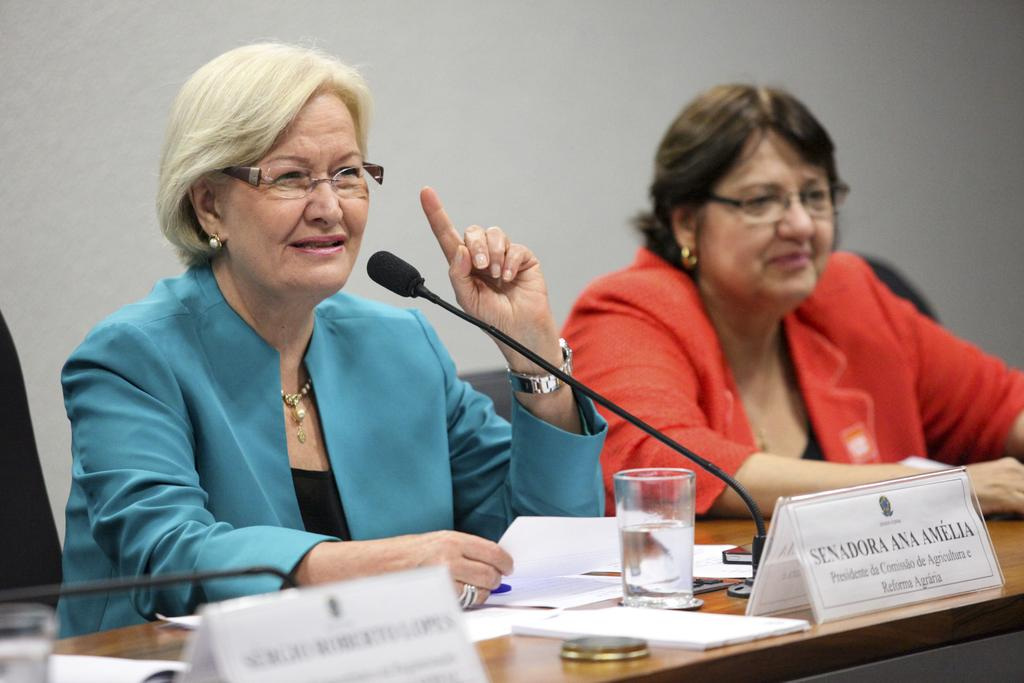How many people are sitting in the image? There are two people sitting on chairs in the image. What objects are visible that might be used for amplifying sound? Microphones are visible in the image. What items are present to identify the people in the image? Name plates are present in the image. What is on the table in the image? There is a glass and papers on the table in the image. How many pizzas are being designed in the image? There are no pizzas present in the image, nor is there any indication of designing anything. 